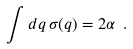<formula> <loc_0><loc_0><loc_500><loc_500>\int d q \, \sigma ( q ) = 2 \alpha \ .</formula> 